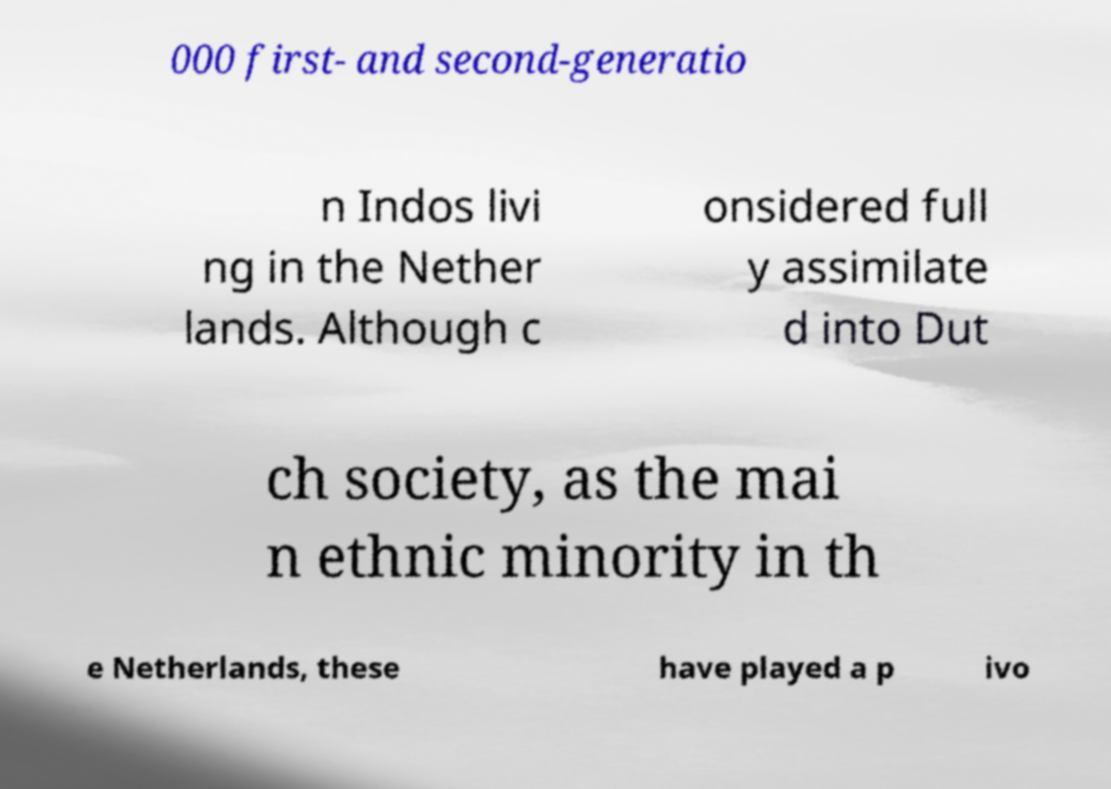Could you extract and type out the text from this image? 000 first- and second-generatio n Indos livi ng in the Nether lands. Although c onsidered full y assimilate d into Dut ch society, as the mai n ethnic minority in th e Netherlands, these have played a p ivo 